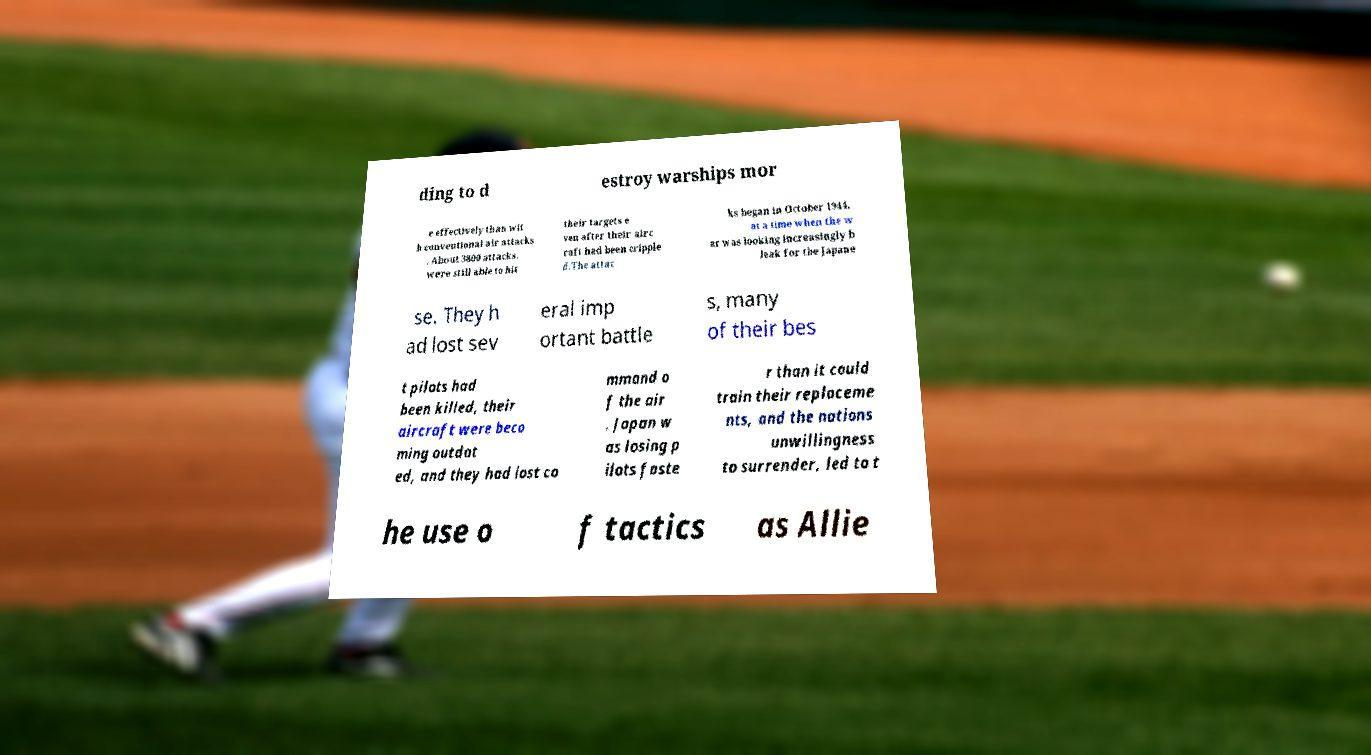Please identify and transcribe the text found in this image. ding to d estroy warships mor e effectively than wit h conventional air attacks . About 3800 attacks. were still able to hit their targets e ven after their airc raft had been cripple d.The attac ks began in October 1944, at a time when the w ar was looking increasingly b leak for the Japane se. They h ad lost sev eral imp ortant battle s, many of their bes t pilots had been killed, their aircraft were beco ming outdat ed, and they had lost co mmand o f the air . Japan w as losing p ilots faste r than it could train their replaceme nts, and the nations unwillingness to surrender, led to t he use o f tactics as Allie 